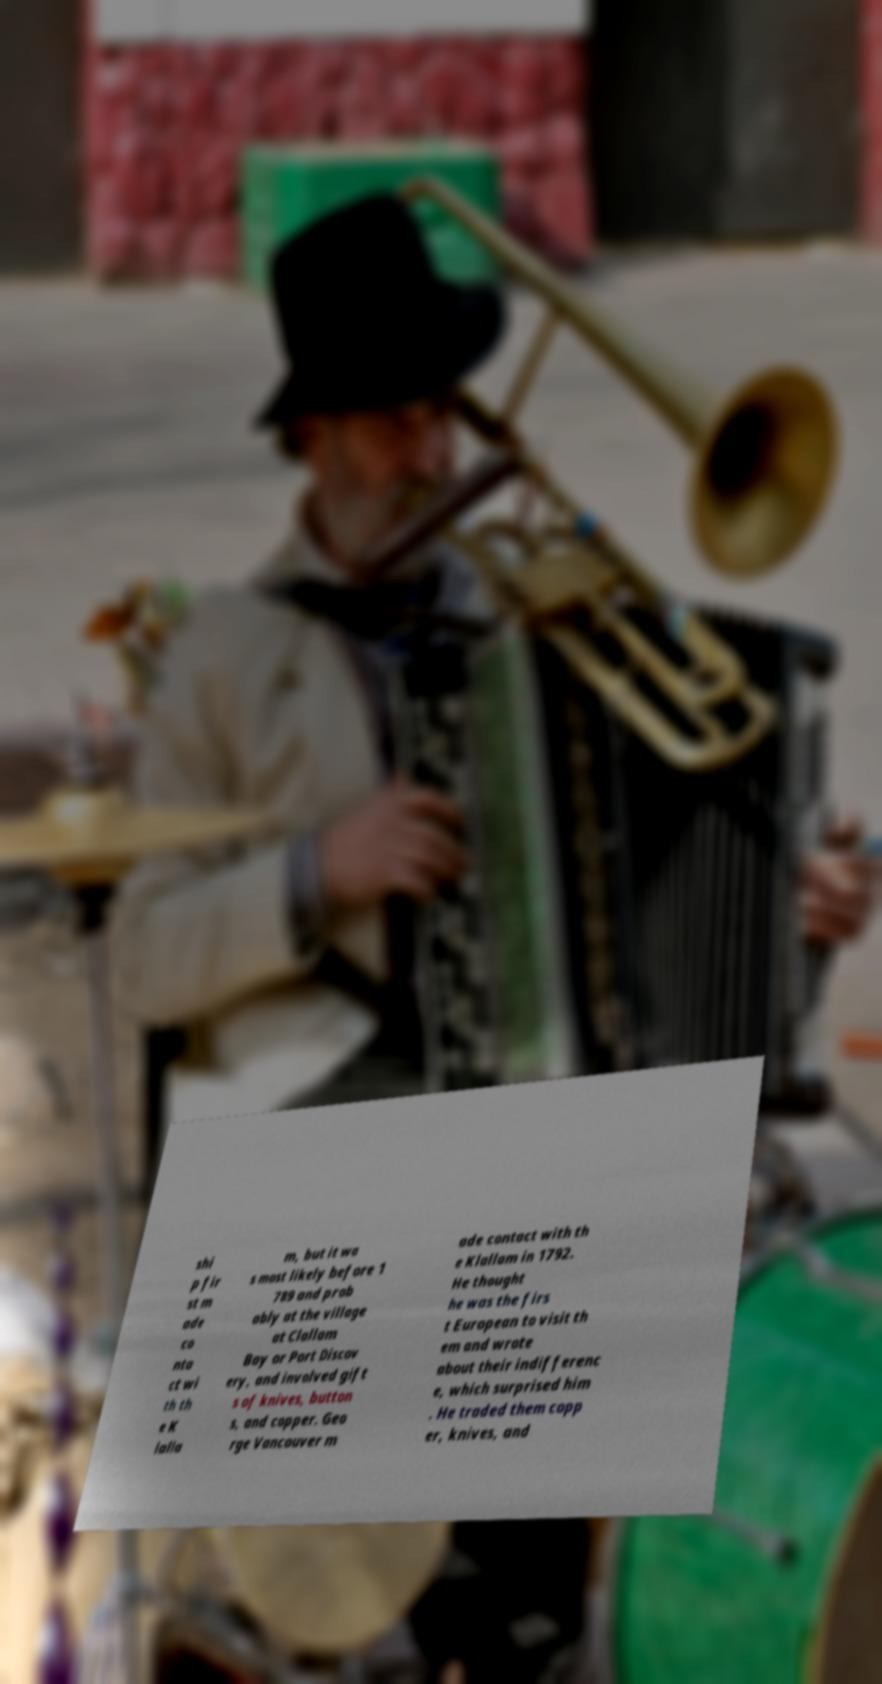There's text embedded in this image that I need extracted. Can you transcribe it verbatim? shi p fir st m ade co nta ct wi th th e K lalla m, but it wa s most likely before 1 789 and prob ably at the village at Clallam Bay or Port Discov ery, and involved gift s of knives, button s, and copper. Geo rge Vancouver m ade contact with th e Klallam in 1792. He thought he was the firs t European to visit th em and wrote about their indifferenc e, which surprised him . He traded them copp er, knives, and 